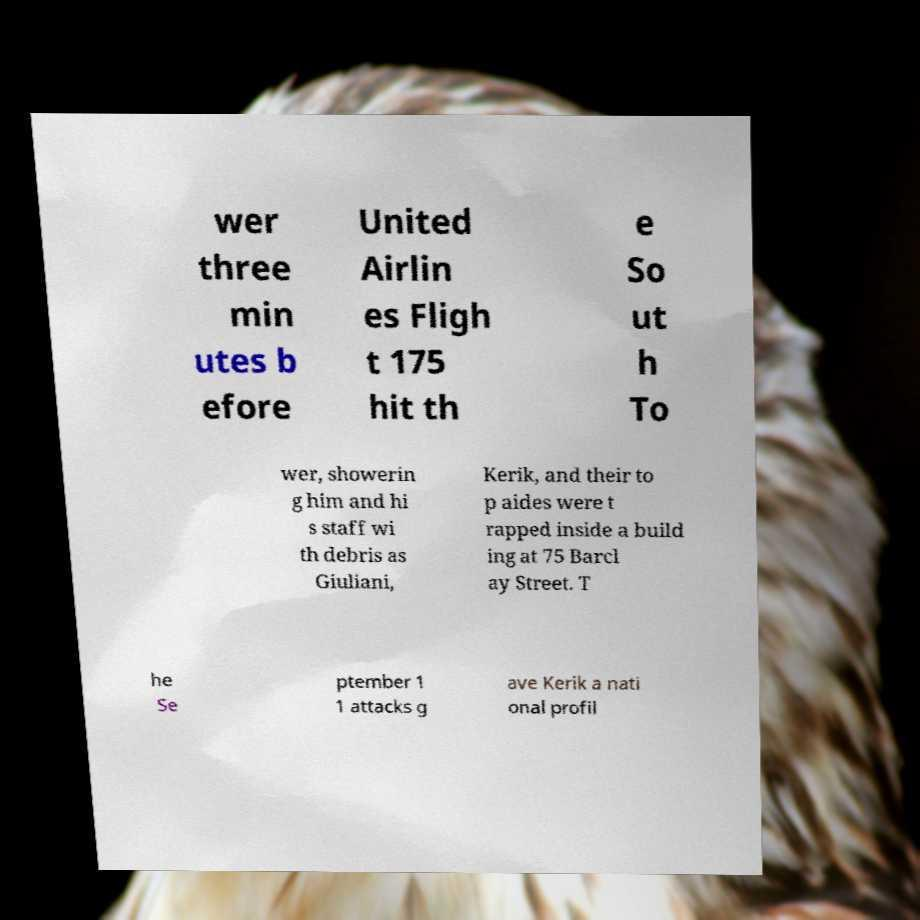Could you assist in decoding the text presented in this image and type it out clearly? wer three min utes b efore United Airlin es Fligh t 175 hit th e So ut h To wer, showerin g him and hi s staff wi th debris as Giuliani, Kerik, and their to p aides were t rapped inside a build ing at 75 Barcl ay Street. T he Se ptember 1 1 attacks g ave Kerik a nati onal profil 